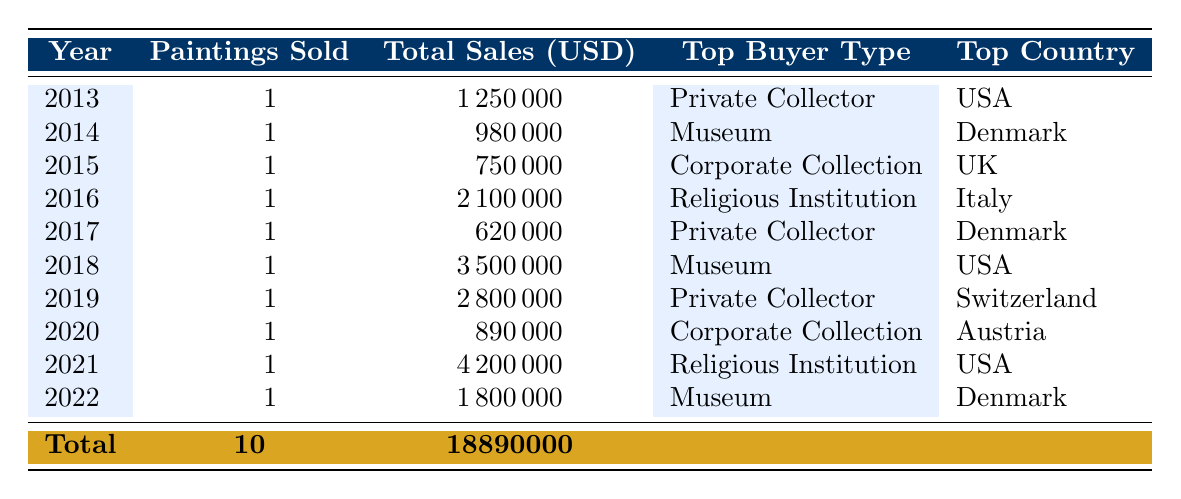What was the highest sale price for Bloch's paintings in the last decade? The highest sale price listed in the table is in 2021 for "The Resurrection," which sold for 4200000 USD.
Answer: 4200000 USD What type of buyer purchased the most expensive painting in the table? The most expensive painting, "The Resurrection," was purchased by a Religious Institution.
Answer: Religious Institution Were there more paintings sold to Private Collectors or Museums over the last decade? According to the table, Private Collectors bought 4 paintings (2013, 2017, 2019) and Museums bought 4 paintings (2014, 2018, 2021, 2022). Thus, both categories have the same number of sales.
Answer: No, they are equal What is the total sales value of Bloch's paintings sold in the USA? The table lists three sales in the USA (2013, 2018, 2021). Summing those sale prices gives 1250000 + 3500000 + 4200000 = 9000000 USD.
Answer: 9000000 USD What was the average sale price of Bloch's paintings sold in Denmark? The sales in Denmark occurred in 2014, 2017, and 2022 with prices of 980000, 620000, and 1800000 USD respectively. Summing these gives 980000 + 620000 + 1800000 = 2800000 USD. To find the average, divide by the number of sales (3), which gives 2800000 / 3 ≈ 933333.33 USD.
Answer: Approximately 933333.33 USD Did any paintings sell for less than 700000 USD? The only painting that sold for less than 700000 USD is "Danish Landscape" in 2017, which sold for 620000 USD.
Answer: Yes How many different auction houses were involved in selling Bloch's paintings in the past decade? The auction houses referenced in the table are Sotheby's, Christie's, Bonhams, Phillips, Dorotheum, and Bruun Rasmussen, which totals six distinct auction houses.
Answer: 6 What was the total number of paintings sold in auctions during 2016? The table indicates that there was one painting sold in 2016, which was “The Annunciation."
Answer: 1 Which country had the highest total sales for Bloch's paintings across the entire period? The USA had sales totaling 9000000 USD from three paintings (2013, 2018, 2021), while other countries (Denmark, UK, Italy, and Austria) contributed less. Thus, the USA has the highest total sales.
Answer: USA 